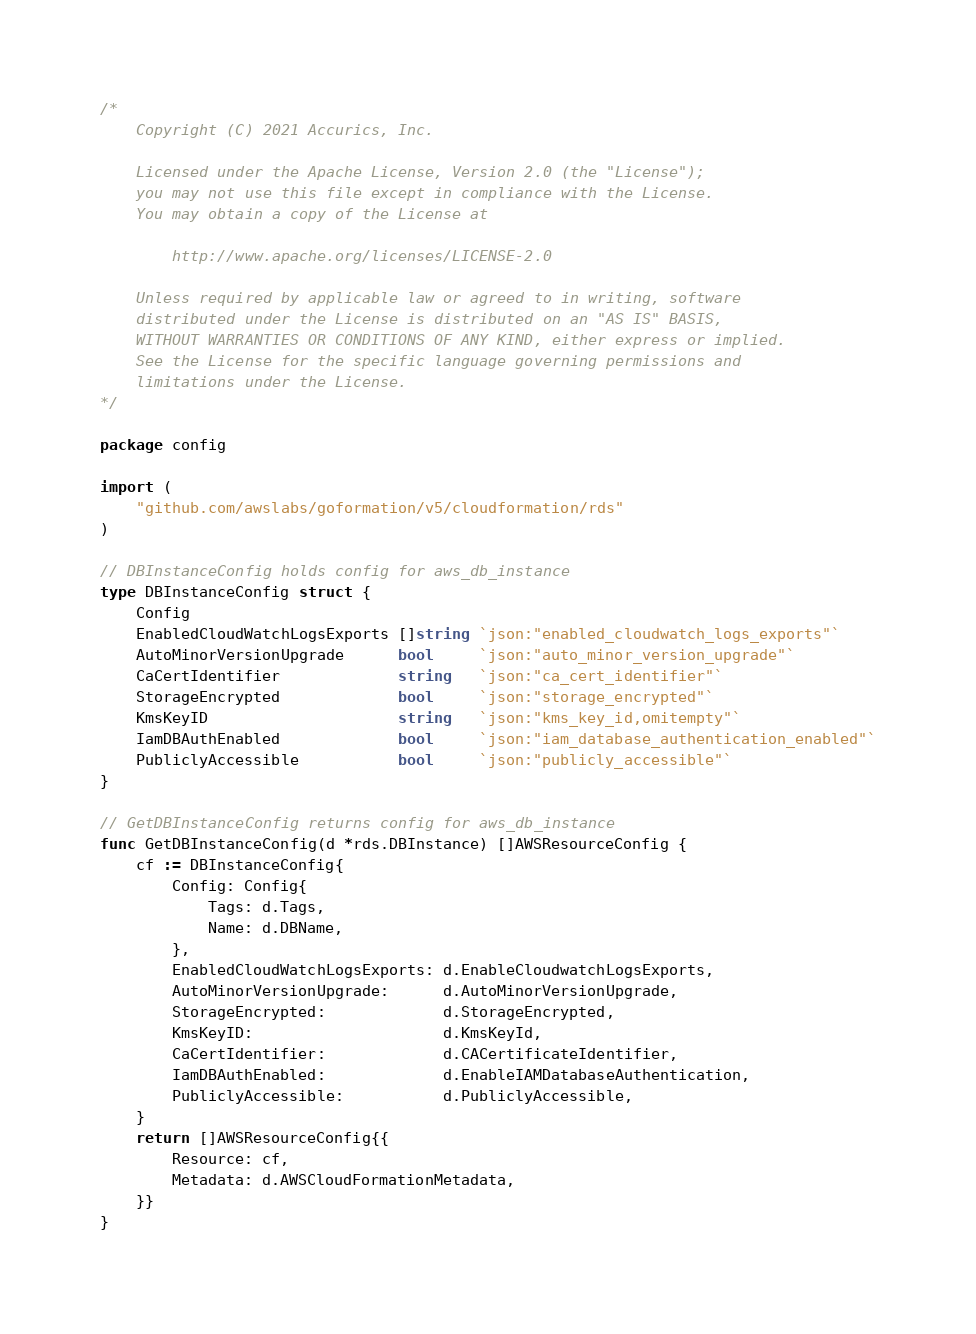Convert code to text. <code><loc_0><loc_0><loc_500><loc_500><_Go_>/*
    Copyright (C) 2021 Accurics, Inc.

	Licensed under the Apache License, Version 2.0 (the "License");
    you may not use this file except in compliance with the License.
    You may obtain a copy of the License at

		http://www.apache.org/licenses/LICENSE-2.0

	Unless required by applicable law or agreed to in writing, software
    distributed under the License is distributed on an "AS IS" BASIS,
    WITHOUT WARRANTIES OR CONDITIONS OF ANY KIND, either express or implied.
    See the License for the specific language governing permissions and
    limitations under the License.
*/

package config

import (
	"github.com/awslabs/goformation/v5/cloudformation/rds"
)

// DBInstanceConfig holds config for aws_db_instance
type DBInstanceConfig struct {
	Config
	EnabledCloudWatchLogsExports []string `json:"enabled_cloudwatch_logs_exports"`
	AutoMinorVersionUpgrade      bool     `json:"auto_minor_version_upgrade"`
	CaCertIdentifier             string   `json:"ca_cert_identifier"`
	StorageEncrypted             bool     `json:"storage_encrypted"`
	KmsKeyID                     string   `json:"kms_key_id,omitempty"`
	IamDBAuthEnabled             bool     `json:"iam_database_authentication_enabled"`
	PubliclyAccessible           bool     `json:"publicly_accessible"`
}

// GetDBInstanceConfig returns config for aws_db_instance
func GetDBInstanceConfig(d *rds.DBInstance) []AWSResourceConfig {
	cf := DBInstanceConfig{
		Config: Config{
			Tags: d.Tags,
			Name: d.DBName,
		},
		EnabledCloudWatchLogsExports: d.EnableCloudwatchLogsExports,
		AutoMinorVersionUpgrade:      d.AutoMinorVersionUpgrade,
		StorageEncrypted:             d.StorageEncrypted,
		KmsKeyID:                     d.KmsKeyId,
		CaCertIdentifier:             d.CACertificateIdentifier,
		IamDBAuthEnabled:             d.EnableIAMDatabaseAuthentication,
		PubliclyAccessible:           d.PubliclyAccessible,
	}
	return []AWSResourceConfig{{
		Resource: cf,
		Metadata: d.AWSCloudFormationMetadata,
	}}
}
</code> 